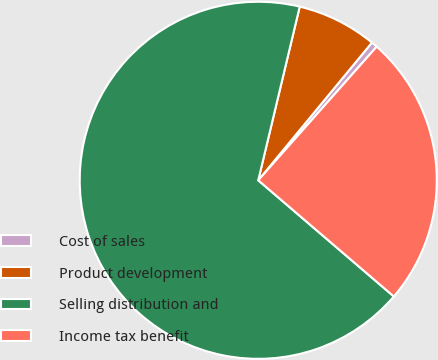<chart> <loc_0><loc_0><loc_500><loc_500><pie_chart><fcel>Cost of sales<fcel>Product development<fcel>Selling distribution and<fcel>Income tax benefit<nl><fcel>0.56%<fcel>7.25%<fcel>67.45%<fcel>24.73%<nl></chart> 